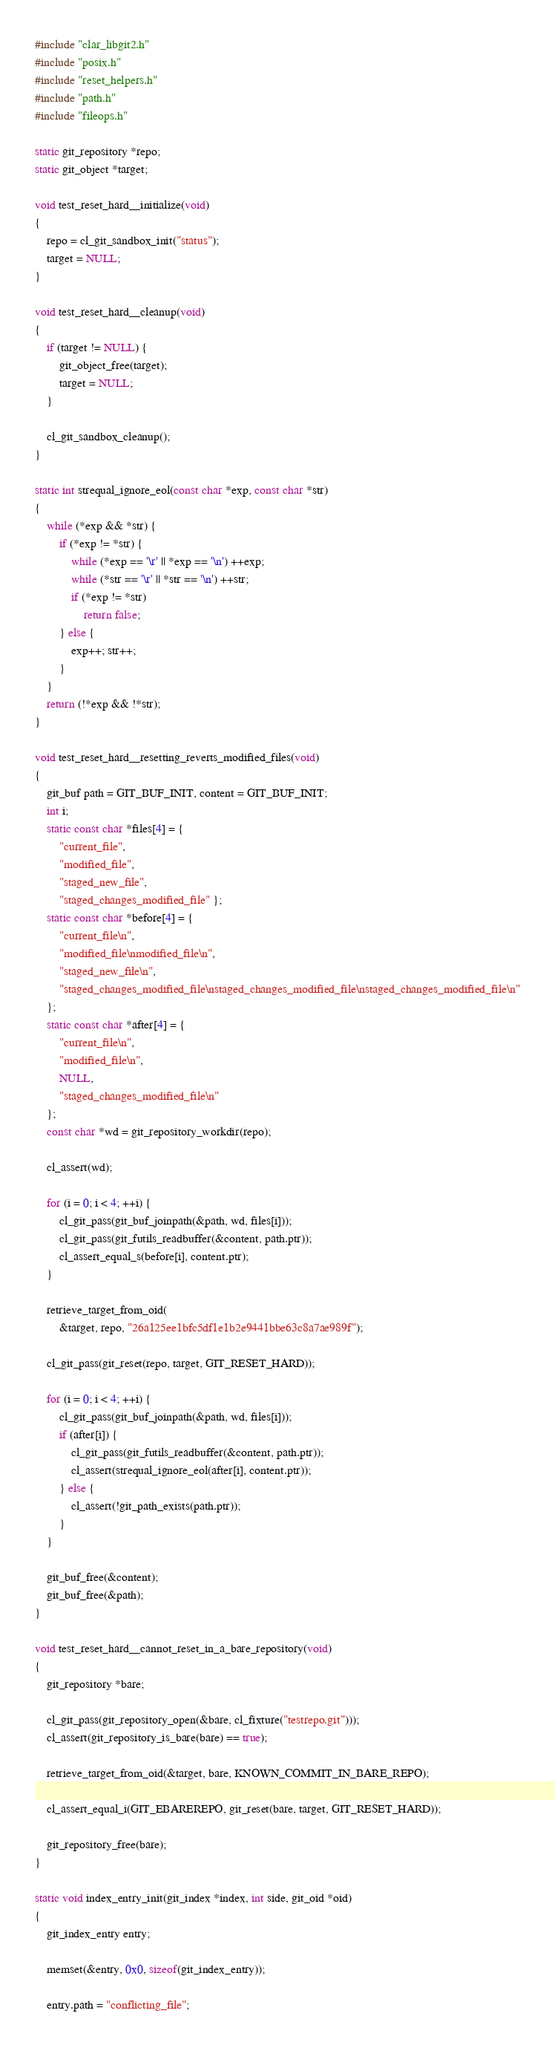<code> <loc_0><loc_0><loc_500><loc_500><_C_>#include "clar_libgit2.h"
#include "posix.h"
#include "reset_helpers.h"
#include "path.h"
#include "fileops.h"

static git_repository *repo;
static git_object *target;

void test_reset_hard__initialize(void)
{
	repo = cl_git_sandbox_init("status");
	target = NULL;
}

void test_reset_hard__cleanup(void)
{
	if (target != NULL) {
		git_object_free(target);
		target = NULL;
	}

	cl_git_sandbox_cleanup();
}

static int strequal_ignore_eol(const char *exp, const char *str)
{
	while (*exp && *str) {
		if (*exp != *str) {
			while (*exp == '\r' || *exp == '\n') ++exp;
			while (*str == '\r' || *str == '\n') ++str;
			if (*exp != *str)
				return false;
		} else {
			exp++; str++;
		}
	}
	return (!*exp && !*str);
}

void test_reset_hard__resetting_reverts_modified_files(void)
{
	git_buf path = GIT_BUF_INIT, content = GIT_BUF_INIT;
	int i;
	static const char *files[4] = {
		"current_file",
		"modified_file",
		"staged_new_file",
		"staged_changes_modified_file" };
	static const char *before[4] = {
		"current_file\n",
		"modified_file\nmodified_file\n",
		"staged_new_file\n",
		"staged_changes_modified_file\nstaged_changes_modified_file\nstaged_changes_modified_file\n"
	};
	static const char *after[4] = {
		"current_file\n",
		"modified_file\n",
		NULL,
		"staged_changes_modified_file\n"
	};
	const char *wd = git_repository_workdir(repo);

	cl_assert(wd);

	for (i = 0; i < 4; ++i) {
		cl_git_pass(git_buf_joinpath(&path, wd, files[i]));
		cl_git_pass(git_futils_readbuffer(&content, path.ptr));
		cl_assert_equal_s(before[i], content.ptr);
	}

	retrieve_target_from_oid(
		&target, repo, "26a125ee1bfc5df1e1b2e9441bbe63c8a7ae989f");

	cl_git_pass(git_reset(repo, target, GIT_RESET_HARD));

	for (i = 0; i < 4; ++i) {
		cl_git_pass(git_buf_joinpath(&path, wd, files[i]));
		if (after[i]) {
			cl_git_pass(git_futils_readbuffer(&content, path.ptr));
			cl_assert(strequal_ignore_eol(after[i], content.ptr));
		} else {
			cl_assert(!git_path_exists(path.ptr));
		}
	}

	git_buf_free(&content);
	git_buf_free(&path);
}

void test_reset_hard__cannot_reset_in_a_bare_repository(void)
{
	git_repository *bare;

	cl_git_pass(git_repository_open(&bare, cl_fixture("testrepo.git")));
	cl_assert(git_repository_is_bare(bare) == true);

	retrieve_target_from_oid(&target, bare, KNOWN_COMMIT_IN_BARE_REPO);

	cl_assert_equal_i(GIT_EBAREREPO, git_reset(bare, target, GIT_RESET_HARD));

	git_repository_free(bare);
}

static void index_entry_init(git_index *index, int side, git_oid *oid)
{
	git_index_entry entry;

	memset(&entry, 0x0, sizeof(git_index_entry));

	entry.path = "conflicting_file";</code> 